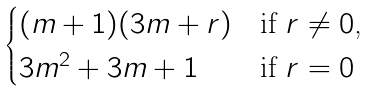<formula> <loc_0><loc_0><loc_500><loc_500>\begin{cases} ( m + 1 ) ( 3 m + r ) & \text {if $r \ne 0$,} \\ 3 m ^ { 2 } + 3 m + 1 & \text {if $r=0$} \end{cases}</formula> 